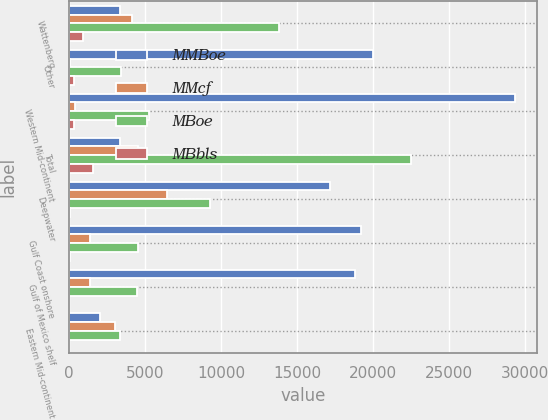<chart> <loc_0><loc_0><loc_500><loc_500><stacked_bar_chart><ecel><fcel>Wattenberg<fcel>Other<fcel>Western Mid-continent<fcel>Total<fcel>Deepwater<fcel>Gulf Coast onshore<fcel>Gulf of Mexico shelf<fcel>Eastern Mid-continent<nl><fcel>MMBoe<fcel>3376<fcel>20001<fcel>29347<fcel>3376<fcel>17195<fcel>19188<fcel>18787<fcel>2033<nl><fcel>MMcf<fcel>4116<fcel>51<fcel>377<fcel>4544<fcel>6417<fcel>1356<fcel>1370<fcel>3028<nl><fcel>MBoe<fcel>13837<fcel>3385<fcel>5268<fcel>22490<fcel>9283<fcel>4554<fcel>4501<fcel>3367<nl><fcel>MBbls<fcel>899<fcel>305<fcel>340<fcel>1544<fcel>77<fcel>88<fcel>13<fcel>17<nl></chart> 